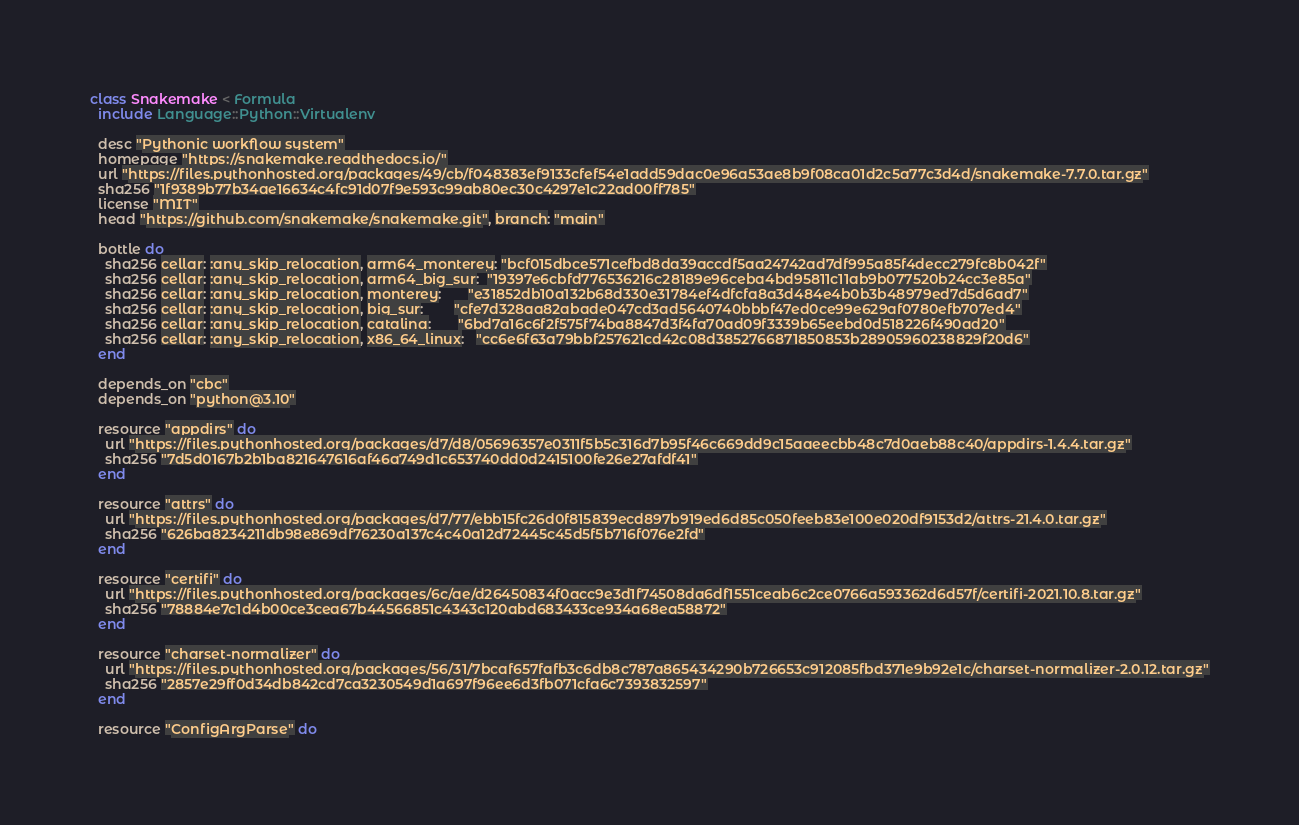<code> <loc_0><loc_0><loc_500><loc_500><_Ruby_>class Snakemake < Formula
  include Language::Python::Virtualenv

  desc "Pythonic workflow system"
  homepage "https://snakemake.readthedocs.io/"
  url "https://files.pythonhosted.org/packages/49/cb/f048383ef9133cfef54e1add59dac0e96a53ae8b9f08ca01d2c5a77c3d4d/snakemake-7.7.0.tar.gz"
  sha256 "1f9389b77b34ae16634c4fc91d07f9e593c99ab80ec30c4297e1c22ad00ff785"
  license "MIT"
  head "https://github.com/snakemake/snakemake.git", branch: "main"

  bottle do
    sha256 cellar: :any_skip_relocation, arm64_monterey: "bcf015dbce571cefbd8da39accdf5aa24742ad7df995a85f4decc279fc8b042f"
    sha256 cellar: :any_skip_relocation, arm64_big_sur:  "19397e6cbfd776536216c28189e96ceba4bd95811c11ab9b077520b24cc3e85a"
    sha256 cellar: :any_skip_relocation, monterey:       "e31852db10a132b68d330e31784ef4dfcfa8a3d484e4b0b3b48979ed7d5d6ad7"
    sha256 cellar: :any_skip_relocation, big_sur:        "cfe7d328aa82abade047cd3ad5640740bbbf47ed0ce99e629af0780efb707ed4"
    sha256 cellar: :any_skip_relocation, catalina:       "6bd7a16c6f2f575f74ba8847d3f4fa70ad09f3339b65eebd0d518226f490ad20"
    sha256 cellar: :any_skip_relocation, x86_64_linux:   "cc6e6f63a79bbf257621cd42c08d3852766871850853b28905960238829f20d6"
  end

  depends_on "cbc"
  depends_on "python@3.10"

  resource "appdirs" do
    url "https://files.pythonhosted.org/packages/d7/d8/05696357e0311f5b5c316d7b95f46c669dd9c15aaeecbb48c7d0aeb88c40/appdirs-1.4.4.tar.gz"
    sha256 "7d5d0167b2b1ba821647616af46a749d1c653740dd0d2415100fe26e27afdf41"
  end

  resource "attrs" do
    url "https://files.pythonhosted.org/packages/d7/77/ebb15fc26d0f815839ecd897b919ed6d85c050feeb83e100e020df9153d2/attrs-21.4.0.tar.gz"
    sha256 "626ba8234211db98e869df76230a137c4c40a12d72445c45d5f5b716f076e2fd"
  end

  resource "certifi" do
    url "https://files.pythonhosted.org/packages/6c/ae/d26450834f0acc9e3d1f74508da6df1551ceab6c2ce0766a593362d6d57f/certifi-2021.10.8.tar.gz"
    sha256 "78884e7c1d4b00ce3cea67b44566851c4343c120abd683433ce934a68ea58872"
  end

  resource "charset-normalizer" do
    url "https://files.pythonhosted.org/packages/56/31/7bcaf657fafb3c6db8c787a865434290b726653c912085fbd371e9b92e1c/charset-normalizer-2.0.12.tar.gz"
    sha256 "2857e29ff0d34db842cd7ca3230549d1a697f96ee6d3fb071cfa6c7393832597"
  end

  resource "ConfigArgParse" do</code> 